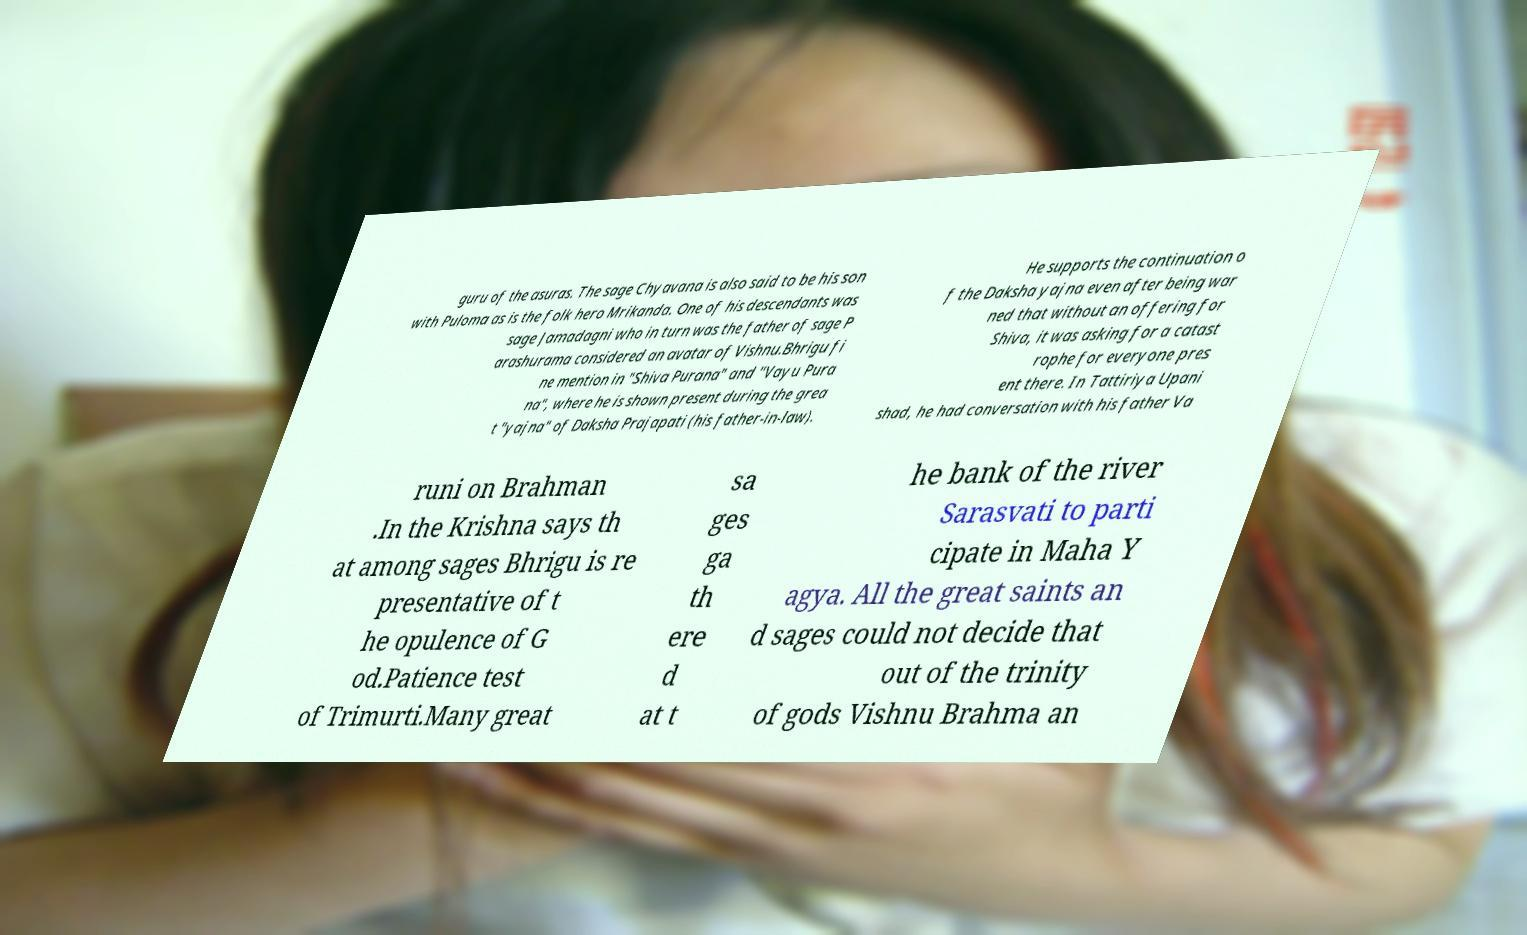Can you accurately transcribe the text from the provided image for me? guru of the asuras. The sage Chyavana is also said to be his son with Puloma as is the folk hero Mrikanda. One of his descendants was sage Jamadagni who in turn was the father of sage P arashurama considered an avatar of Vishnu.Bhrigu fi ne mention in "Shiva Purana" and "Vayu Pura na", where he is shown present during the grea t "yajna" of Daksha Prajapati (his father-in-law). He supports the continuation o f the Daksha yajna even after being war ned that without an offering for Shiva, it was asking for a catast rophe for everyone pres ent there. In Tattiriya Upani shad, he had conversation with his father Va runi on Brahman .In the Krishna says th at among sages Bhrigu is re presentative of t he opulence of G od.Patience test of Trimurti.Many great sa ges ga th ere d at t he bank of the river Sarasvati to parti cipate in Maha Y agya. All the great saints an d sages could not decide that out of the trinity of gods Vishnu Brahma an 